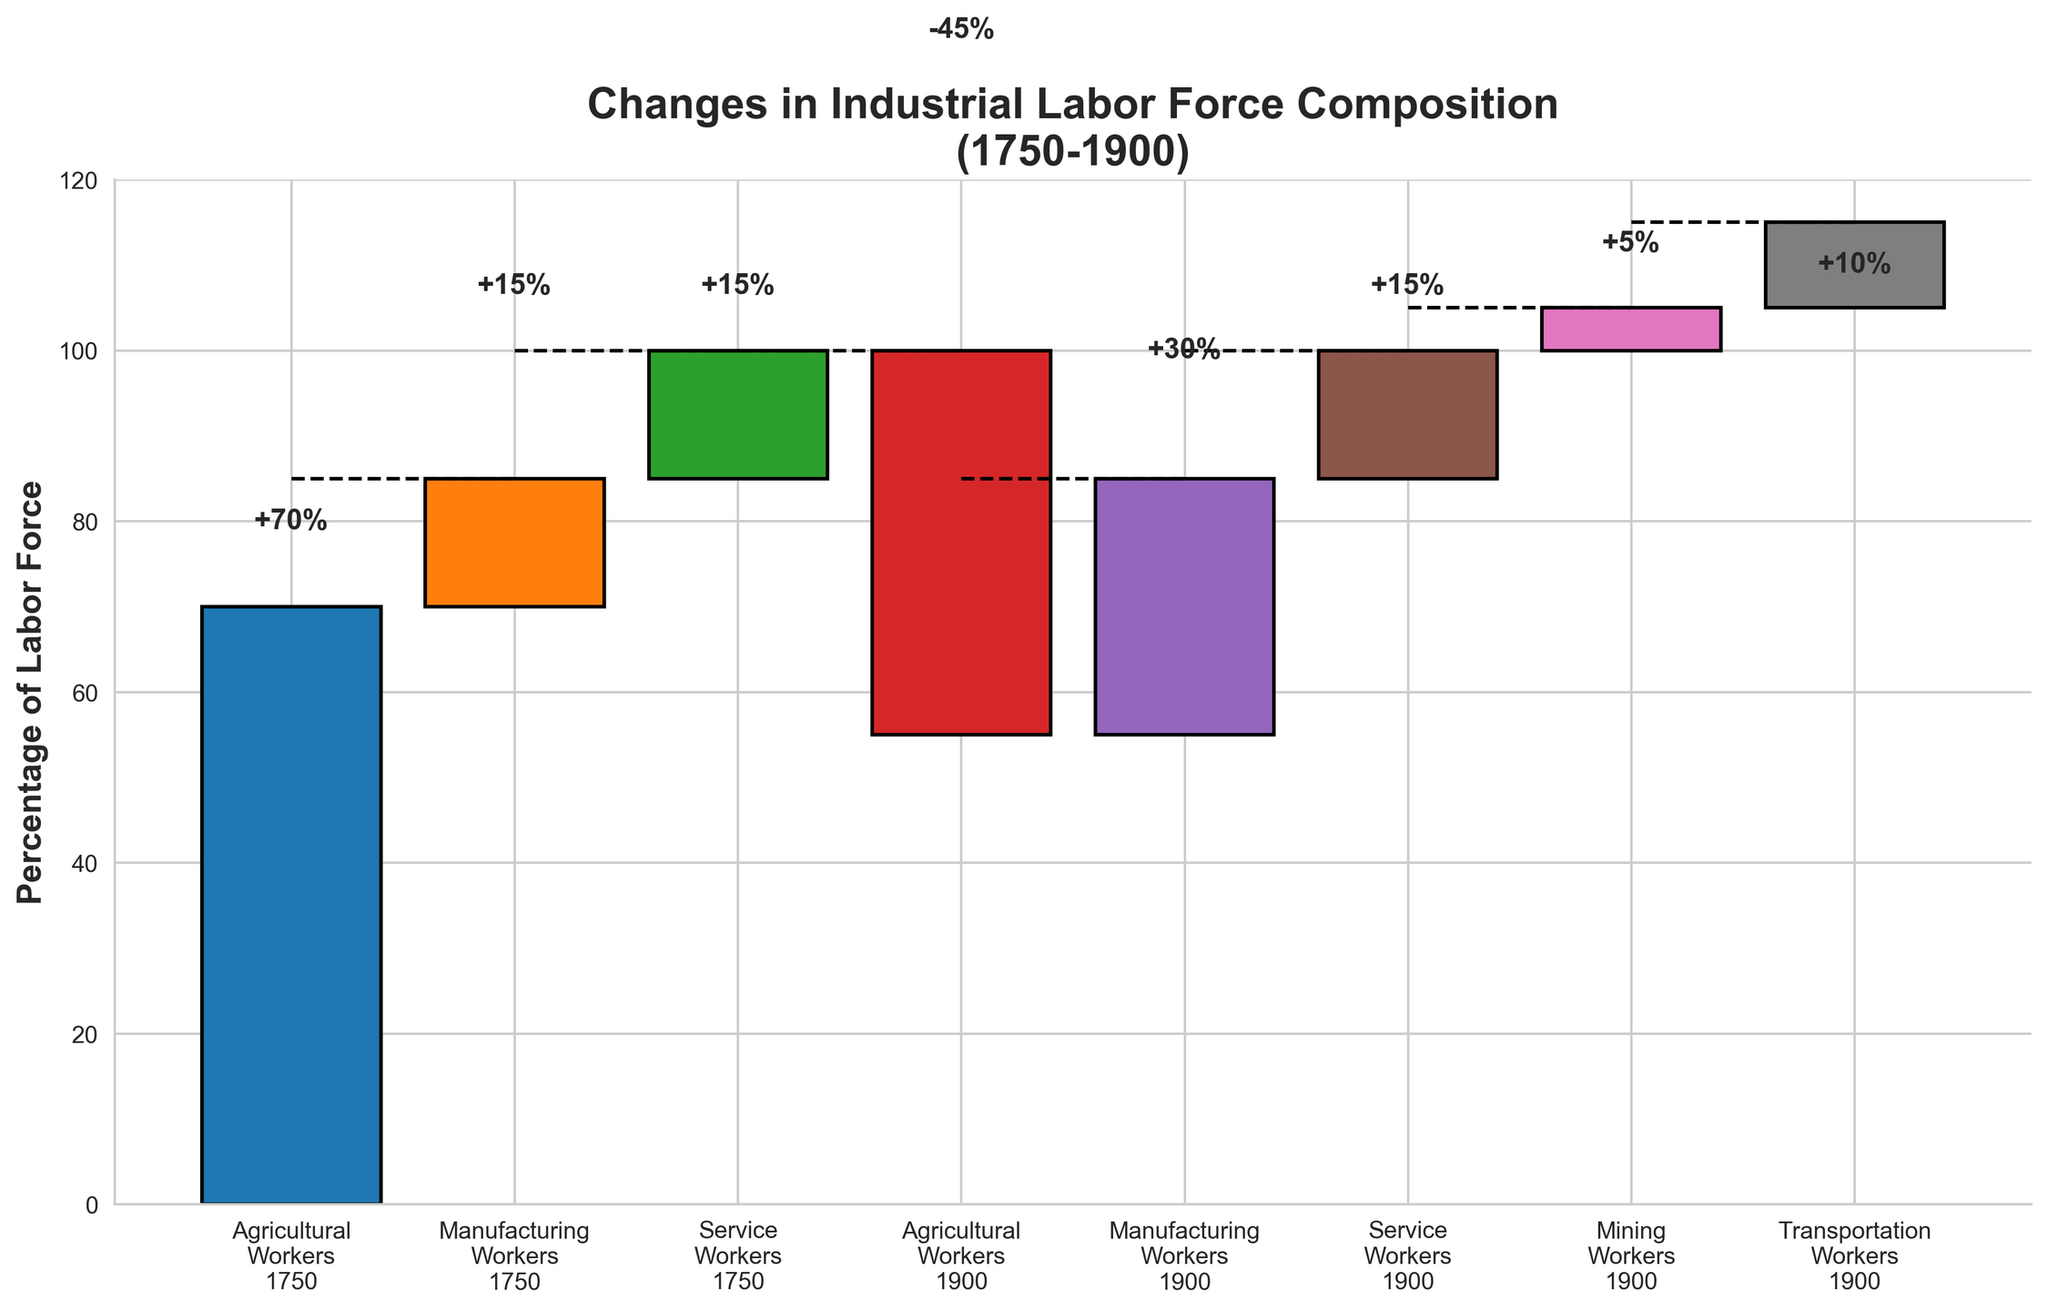What is the title of the chart? The title is usually displayed prominently at the top of the chart. Here, it states "Changes in Industrial Labor Force Composition (1750-1900)"
Answer: Changes in Industrial Labor Force Composition (1750-1900) What is the percentage change for Agricultural Workers from 1750 to 1900? The chart shows a bar for Agricultural Workers 1750 at 70 and a bar for Agricultural Workers 1900 at -45. To find the change, subtract -45 from 70.
Answer: 70 - 45 = 25% How much did the manufacturing workforce increase by 1900? The bar for Manufacturing Workers 1750 is at 15, and the bar for Manufacturing Workers 1900 is at 30. The increase can be calculated by subtracting 15 from 30.
Answer: 30 - 15 = 15% How do the percentages of Service Workers compare between 1750 and 1900? The chart shows the bar for Service Workers 1750 at 15 and the bar for Service Workers 1900 at 15. Since they both have the same value, the percentage hasn't changed.
Answer: Equal; 0% change Which category experienced the smallest change over the period? Comparing all bars, Service Workers started and ended at 15, indicating no change.
Answer: Service Workers What is the net percentage increase from Manufacturing, Mining, Transportation, and Service Workers combined by 1900? Sum the percentages for Manufacturing Workers 1900 (30), Mining Workers 1900 (5), Transportation Workers 1900 (10), and Service Workers 1900 (15).
Answer: 30 + 5 + 10 + 15 = 60% Which category had a decrease in the labor force composition? Inspect the chart to see which bar has a negative value for 1900. It shows only Agricultural Workers 1900 with a negative value of -45.
Answer: Agricultural Workers What was the total labor force percentage in 1750 compared to 1900? Add the given values for 1750 categories (70 + 15 + 15 = 100) and for 1900 categories (subtracting decrease and adding increases: -45 + 30 + 15 + 5 + 10 = 15, summing: 70 + 15 + 15 + 15 = 115).
Answer: 100% in 1750; 115% in 1900 Are there any new categories of workers in 1900 that were not present in 1750? The chart adds bars for Mining Workers (5) and Transportation Workers (10) only for 1900, indicating they were not present in 1750.
Answer: Mining Workers and Transportation Workers What was the combined percentage of Agricultural and Manufacturing Workers in 1750? Add the values for Agricultural Workers 1750 (70) and Manufacturing Workers 1750 (15).
Answer: 70 + 15 = 85% 